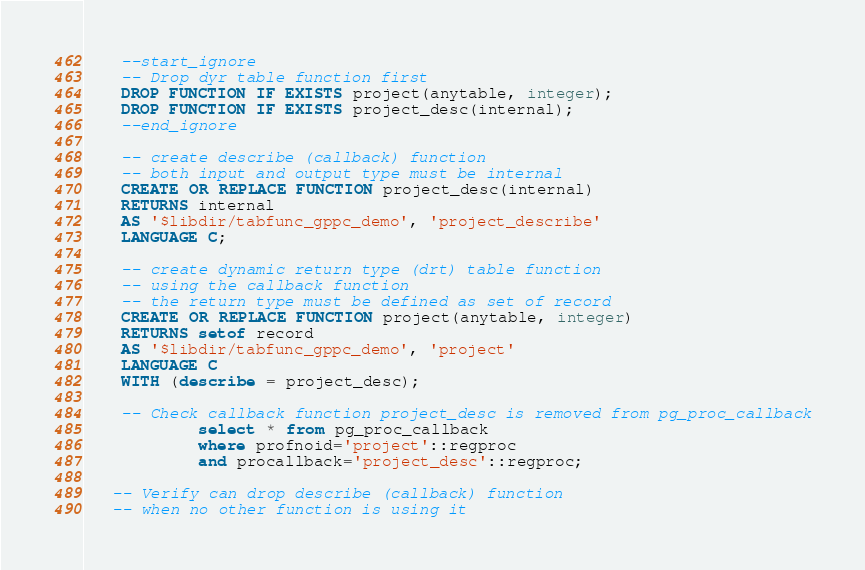Convert code to text. <code><loc_0><loc_0><loc_500><loc_500><_SQL_>    --start_ignore
    -- Drop dyr table function first
    DROP FUNCTION IF EXISTS project(anytable, integer);
    DROP FUNCTION IF EXISTS project_desc(internal);
    --end_ignore

    -- create describe (callback) function
    -- both input and output type must be internal
    CREATE OR REPLACE FUNCTION project_desc(internal)
    RETURNS internal
    AS '$libdir/tabfunc_gppc_demo', 'project_describe'
    LANGUAGE C;

    -- create dynamic return type (drt) table function
    -- using the callback function
    -- the return type must be defined as set of record
    CREATE OR REPLACE FUNCTION project(anytable, integer)
    RETURNS setof record
    AS '$libdir/tabfunc_gppc_demo', 'project'
    LANGUAGE C
    WITH (describe = project_desc);

    -- Check callback function project_desc is removed from pg_proc_callback
            select * from pg_proc_callback 
            where profnoid='project'::regproc 
            and procallback='project_desc'::regproc;

   -- Verify can drop describe (callback) function 
   -- when no other function is using it
</code> 